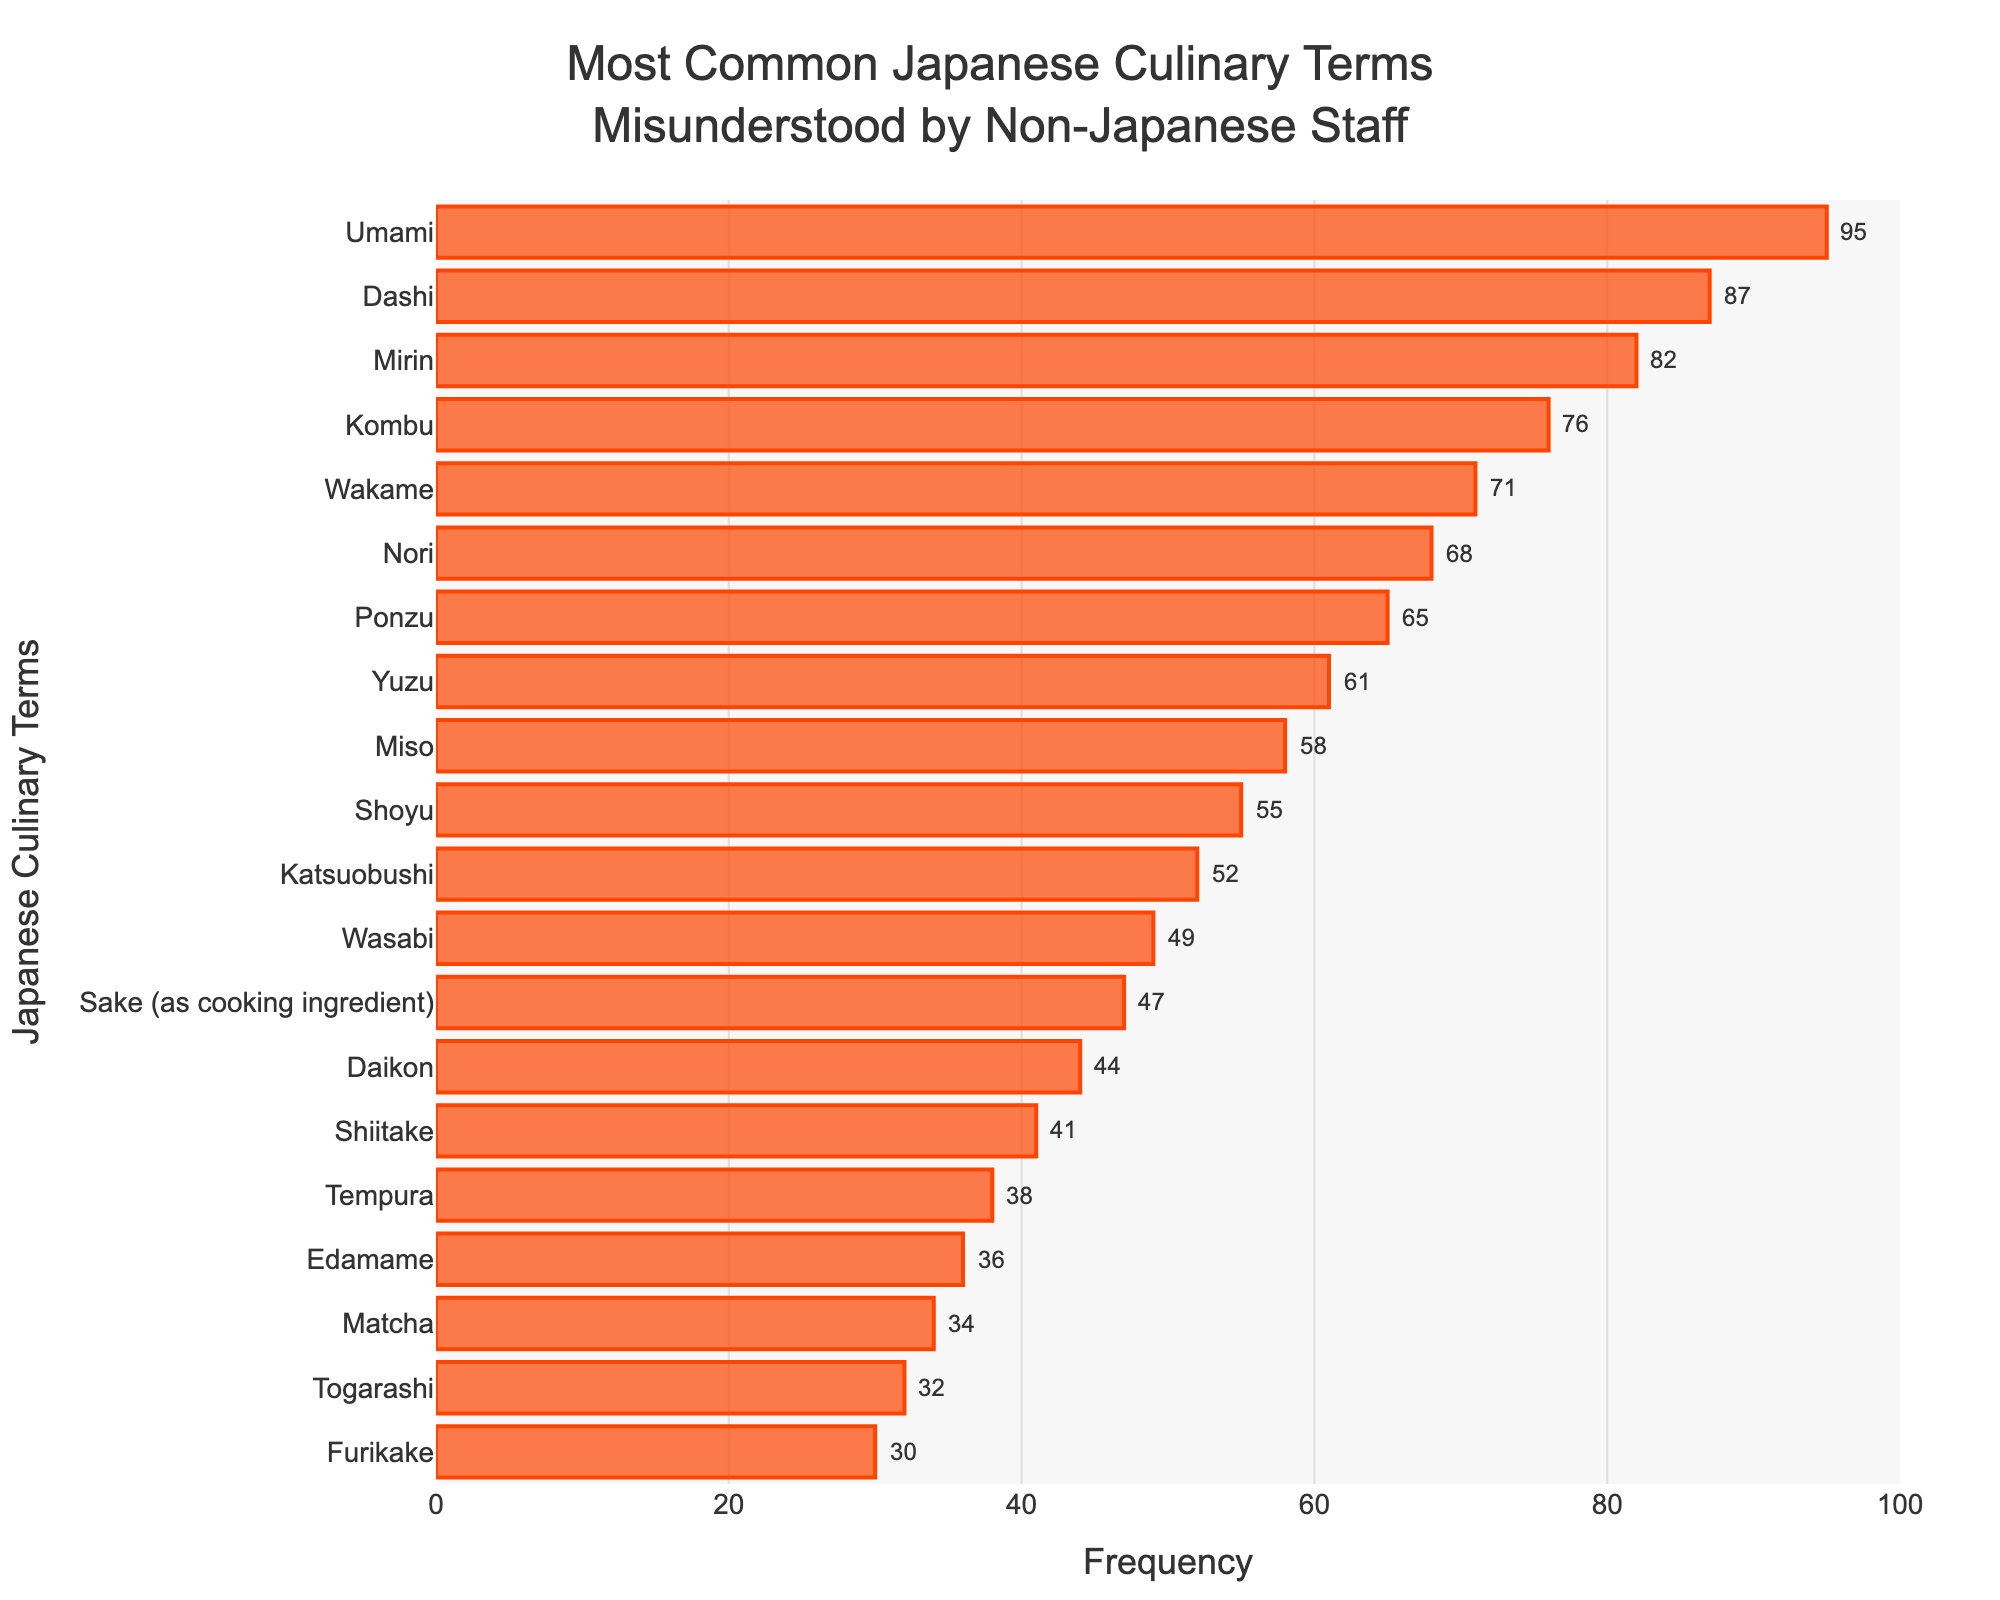Which term is misunderstood the most frequently? By referring to the bar chart, the term with the longest bar is Umami, which indicates it has the highest frequency of 95.
Answer: Umami Which term is misunderstood the least frequently? The term with the shortest bar is Furikake, indicating it has the lowest frequency of 30.
Answer: Furikake What is the difference in frequency between the most and least misunderstood terms? The most misunderstood term is Umami with a frequency of 95, and the least misunderstood is Furikake with a frequency of 30. The difference is 95 - 30.
Answer: 65 Which term is the 5th most misunderstood? By counting down the bars from the top of the chart to the 5th position, Kombu is at the 5th position with a frequency of 76.
Answer: Kombu How many terms have a misunderstanding frequency of at least 50? By counting the bars in the chart with a frequency of 50 or more: Umami, Dashi, Mirin, Kombu, Wakame, Nori, Ponzu, Yuzu, Miso, Shoyu, and Katsuobushi. There are 11 terms.
Answer: 11 What is the sum of the frequencies of the top three most misunderstood terms? The top three terms are Umami, Dashi, and Mirin with frequencies 95, 87, and 82 respectively. The sum is 95 + 87 + 82.
Answer: 264 Which has a higher misunderstanding frequency, Yuzu or Miso? By comparing the lengths of the bars for each term, Yuzu has a frequency of 61 while Miso has a frequency of 58. Therefore, Yuzu has a higher frequency.
Answer: Yuzu How much more frequently is Togarashi misunderstood compared to Furikake? The bar for Togarashi shows a frequency of 32, while the bar for Furikake shows 30. The difference is 32 - 30.
Answer: 2 What is the average frequency of misunderstanding for the terms Miso, Shoyu, and Katsuobushi? The frequencies are 58 for Miso, 55 for Shoyu, and 52 for Katsuobushi. The sum is 58 + 55 + 52 = 165. The average is 165/3.
Answer: 55 